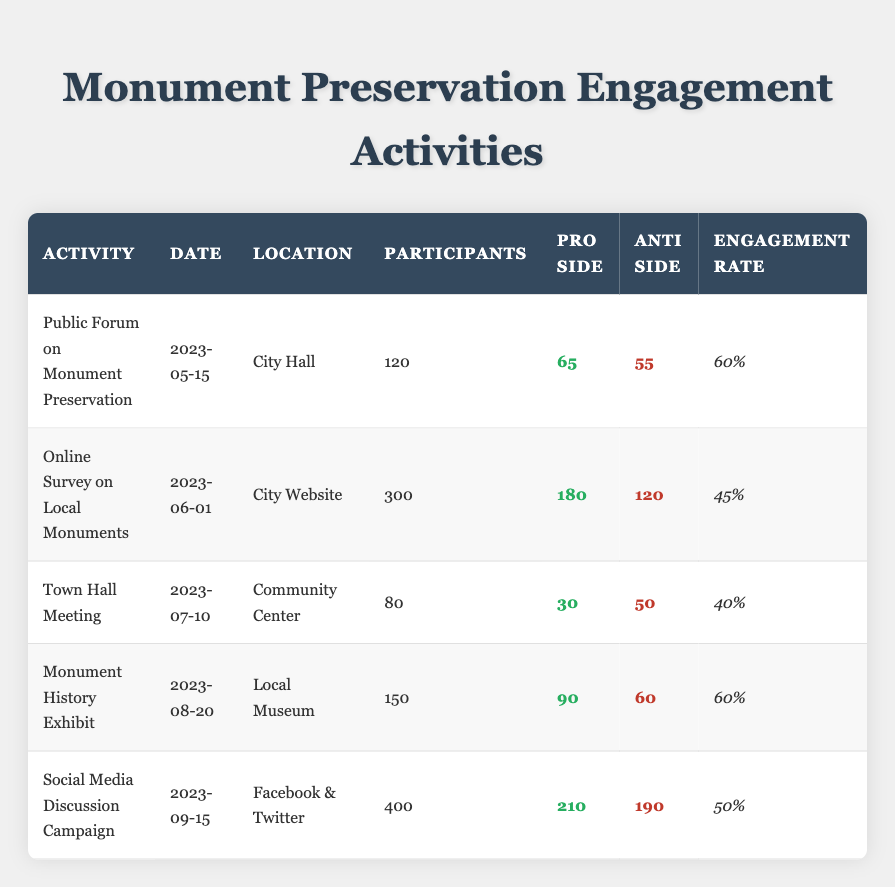What is the total number of participants across all engagement activities? To find the total number of participants, we add the participants from each activity: 120 (Public Forum) + 300 (Online Survey) + 80 (Town Hall) + 150 (Exhibit) + 400 (Social Media) = 1050.
Answer: 1050 Which activity had the highest engagement rate? By comparing the engagement rates in the table, we see that the Public Forum on Monument Preservation and the Monument History Exhibit both have the highest engagement rate of 60%.
Answer: Public Forum and Monument History Exhibit How many participants were pro-monument preservation in the Online Survey? Referring to the table, the Online Survey on Local Monuments had 180 participants on the pro side.
Answer: 180 Are there more participants on the pro side or anti side at the Town Hall Meeting? In the Town Hall Meeting, the pro side had 30 participants and the anti side had 50 participants. Since 50 is greater than 30, there are more anti participants.
Answer: Anti side What is the average number of participants across all activities? To find the average, sum the participants (120 + 300 + 80 + 150 + 400 = 1050) and divide by the number of activities (5): 1050/5 = 210.
Answer: 210 What percentage of participants in the Social Media Discussion Campaign were anti-monument preservation? The Social Media Campaign had 400 participants, with 190 on the anti side. To find the percentage, divide 190 by 400 and multiply by 100: (190/400)*100 = 47.5%.
Answer: 47.5% Did the Monument History Exhibit have more pro or anti side participants? The Monument History Exhibit had 90 pro participants and 60 anti participants. Since 90 is greater than 60, there were more pro participants.
Answer: Yes What is the difference in the number of participants between the pro and anti sides in the Public Forum on Monument Preservation? In the Public Forum, there were 65 pro participants and 55 anti participants. The difference is calculated as 65 - 55 = 10.
Answer: 10 Which location had the fewest participants in its activity? The table shows the Town Hall Meeting had the fewest participants with a total of 80.
Answer: Community Center 